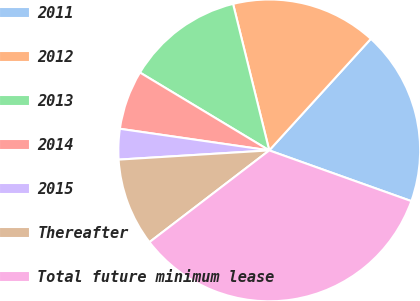Convert chart. <chart><loc_0><loc_0><loc_500><loc_500><pie_chart><fcel>2011<fcel>2012<fcel>2013<fcel>2014<fcel>2015<fcel>Thereafter<fcel>Total future minimum lease<nl><fcel>18.7%<fcel>15.61%<fcel>12.52%<fcel>6.34%<fcel>3.26%<fcel>9.43%<fcel>34.14%<nl></chart> 